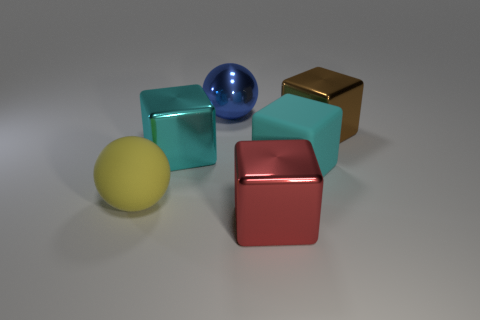How many other things are there of the same shape as the large blue object?
Your response must be concise. 1. Is the color of the matte ball the same as the shiny sphere?
Your response must be concise. No. How many objects are brown things or metallic blocks that are behind the large yellow ball?
Your answer should be compact. 2. Are there any cyan objects that have the same size as the rubber block?
Give a very brief answer. Yes. Does the red cube have the same material as the yellow ball?
Offer a terse response. No. How many things are shiny objects or large blue things?
Offer a very short reply. 4. The brown metal block has what size?
Offer a terse response. Large. Are there fewer small purple things than cyan cubes?
Provide a short and direct response. Yes. What number of big things have the same color as the matte block?
Provide a succinct answer. 1. Do the large sphere that is in front of the big brown block and the big metallic ball have the same color?
Keep it short and to the point. No. 